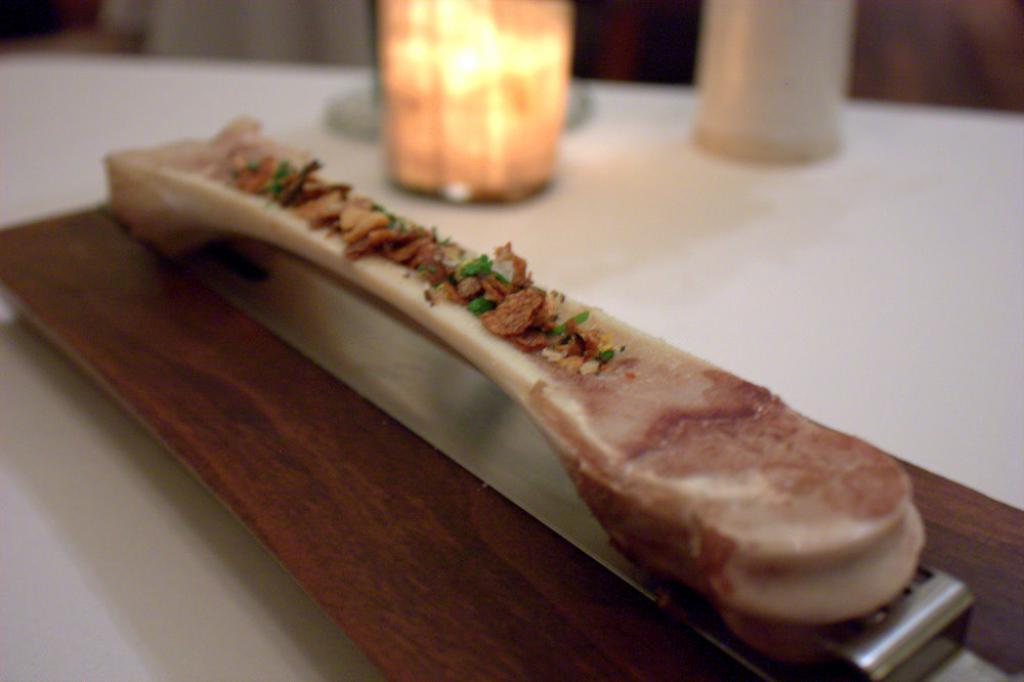What is the main subject of the image? There is a food item in the image. On what surface is the food item placed? The food item is on a wooden board. How many cards are being used for learning in the image? There are no cards or any indication of learning activities present in the image. 